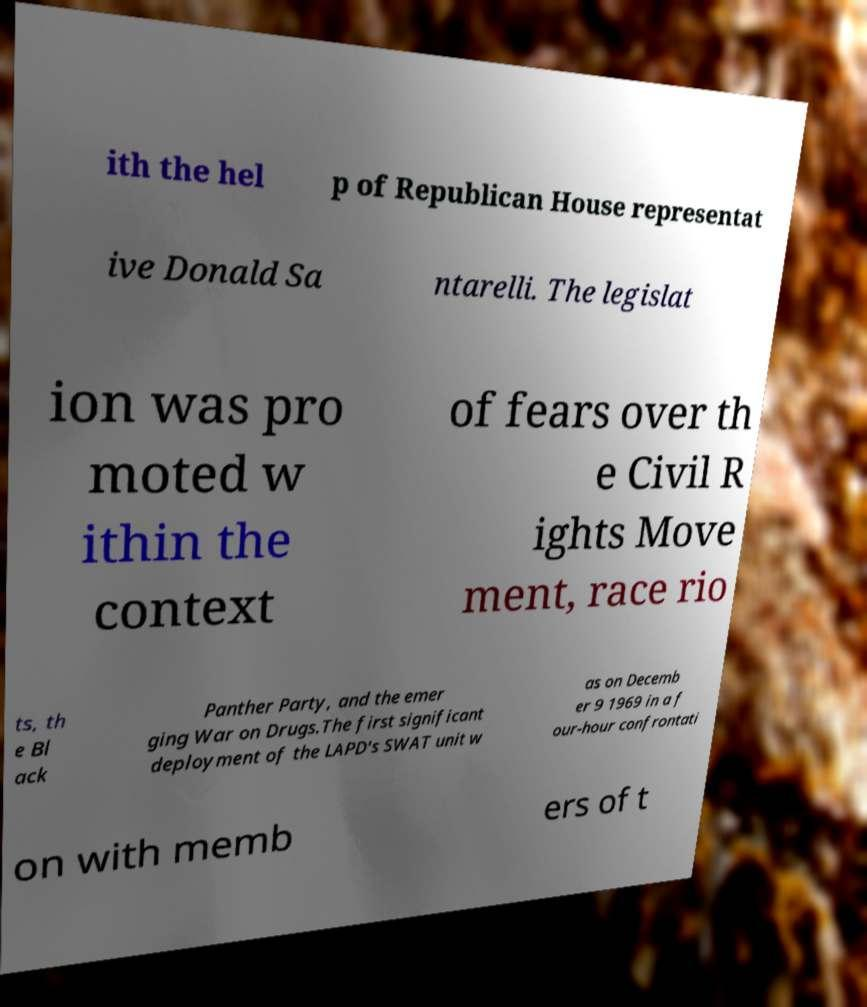I need the written content from this picture converted into text. Can you do that? ith the hel p of Republican House representat ive Donald Sa ntarelli. The legislat ion was pro moted w ithin the context of fears over th e Civil R ights Move ment, race rio ts, th e Bl ack Panther Party, and the emer ging War on Drugs.The first significant deployment of the LAPD's SWAT unit w as on Decemb er 9 1969 in a f our-hour confrontati on with memb ers of t 